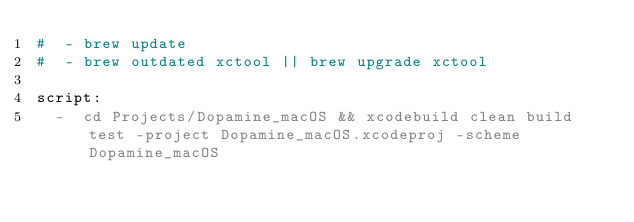<code> <loc_0><loc_0><loc_500><loc_500><_YAML_>#  - brew update
#  - brew outdated xctool || brew upgrade xctool

script:
  -  cd Projects/Dopamine_macOS && xcodebuild clean build test -project Dopamine_macOS.xcodeproj -scheme Dopamine_macOS
</code> 